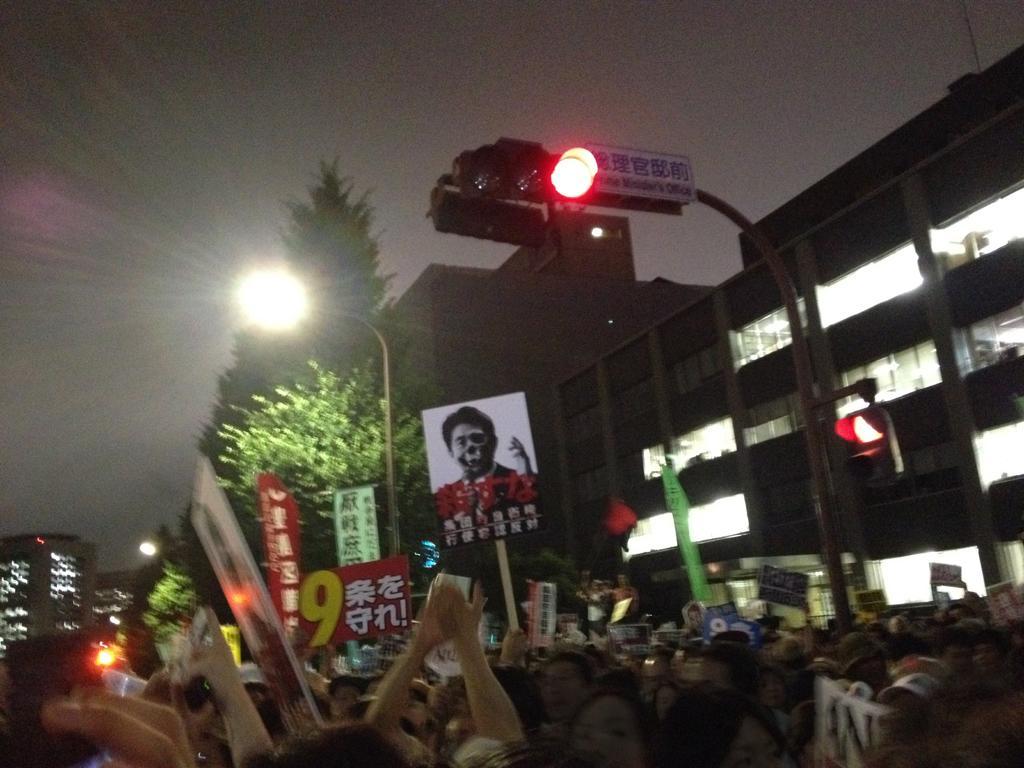Describe this image in one or two sentences. In this image I can see the group of people. In the back there are many banners and boards can be seen. I can also see the trees and light poles. To the right I can see the building. In the back I can see the sky. 